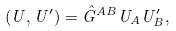Convert formula to latex. <formula><loc_0><loc_0><loc_500><loc_500>( U , U ^ { \prime } ) = \hat { G } ^ { A B } U _ { A } U ^ { \prime } _ { B } ,</formula> 